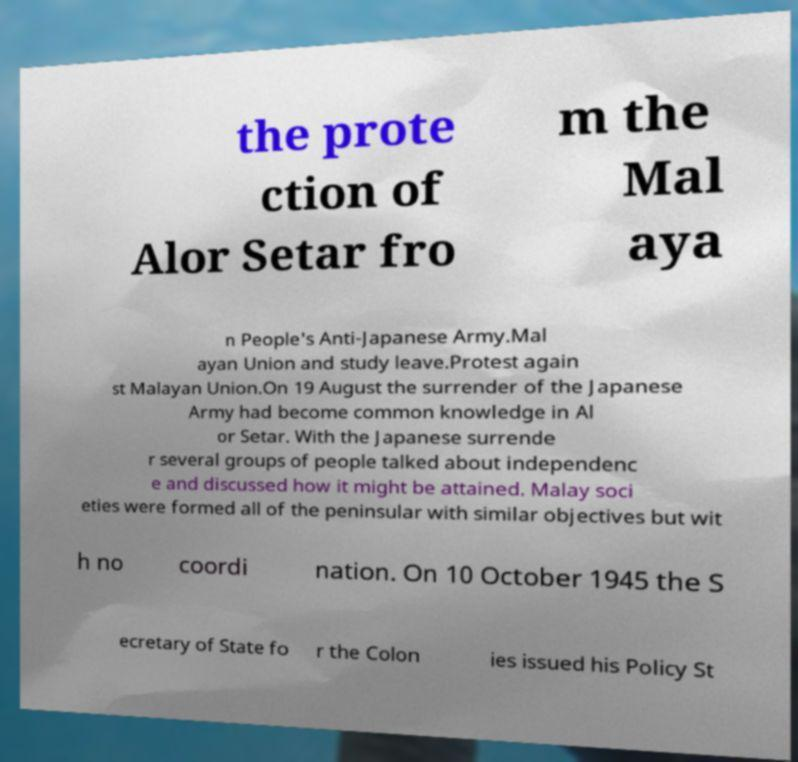Could you assist in decoding the text presented in this image and type it out clearly? the prote ction of Alor Setar fro m the Mal aya n People's Anti-Japanese Army.Mal ayan Union and study leave.Protest again st Malayan Union.On 19 August the surrender of the Japanese Army had become common knowledge in Al or Setar. With the Japanese surrende r several groups of people talked about independenc e and discussed how it might be attained. Malay soci eties were formed all of the peninsular with similar objectives but wit h no coordi nation. On 10 October 1945 the S ecretary of State fo r the Colon ies issued his Policy St 